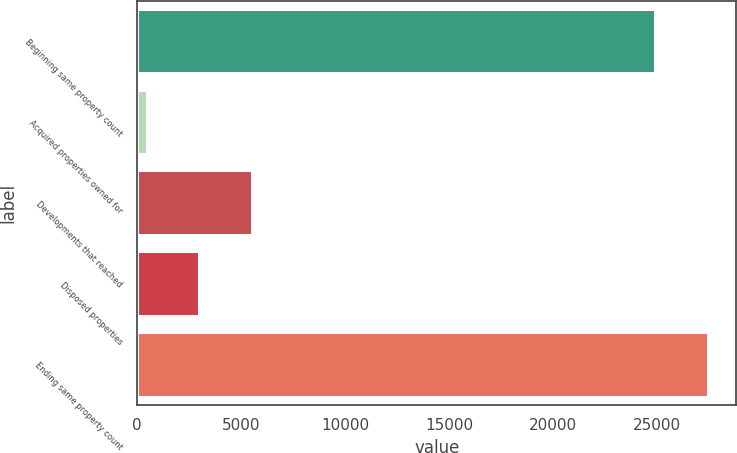Convert chart. <chart><loc_0><loc_0><loc_500><loc_500><bar_chart><fcel>Beginning same property count<fcel>Acquired properties owned for<fcel>Developments that reached<fcel>Disposed properties<fcel>Ending same property count<nl><fcel>24922<fcel>465<fcel>5532.6<fcel>2998.8<fcel>27455.8<nl></chart> 